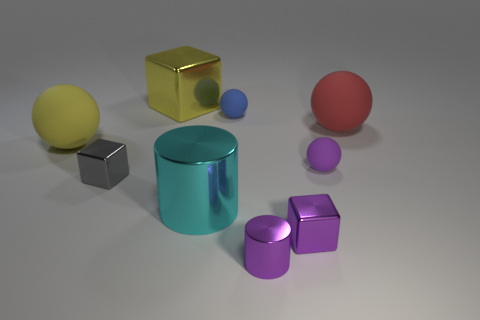Subtract all green cubes. Subtract all gray balls. How many cubes are left? 3 Add 1 small purple matte things. How many objects exist? 10 Subtract all cylinders. How many objects are left? 7 Subtract 0 red blocks. How many objects are left? 9 Subtract all tiny cylinders. Subtract all purple things. How many objects are left? 5 Add 6 cyan metallic cylinders. How many cyan metallic cylinders are left? 7 Add 9 large blue rubber cylinders. How many large blue rubber cylinders exist? 9 